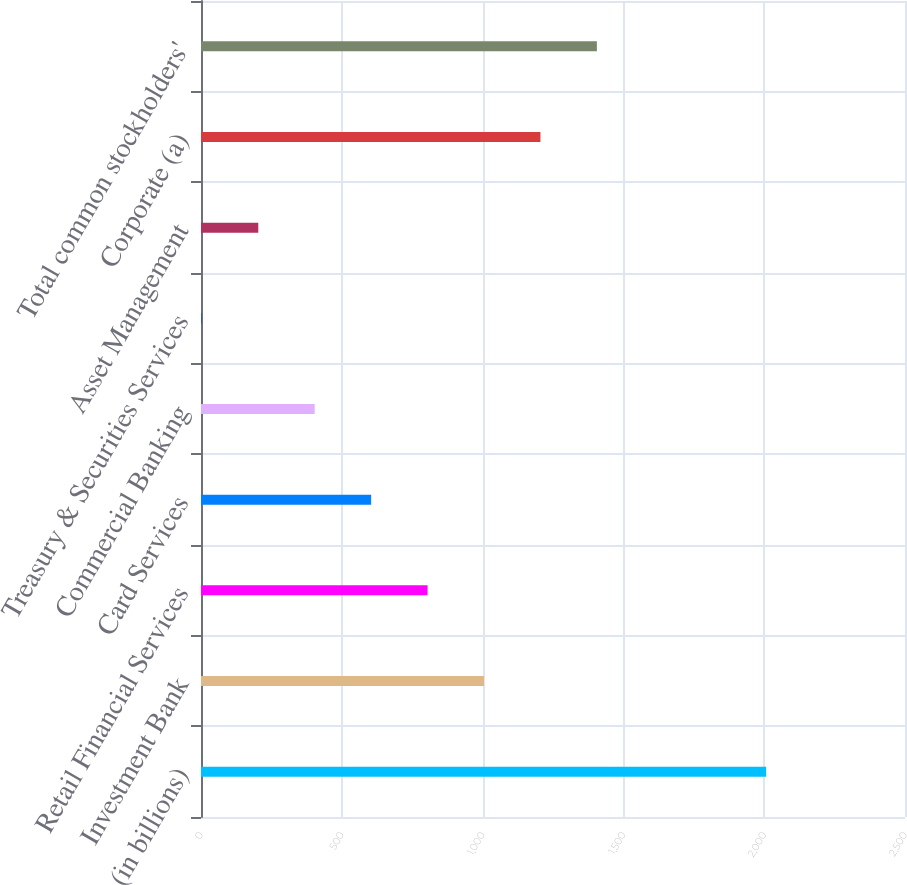Convert chart. <chart><loc_0><loc_0><loc_500><loc_500><bar_chart><fcel>(in billions)<fcel>Investment Bank<fcel>Retail Financial Services<fcel>Card Services<fcel>Commercial Banking<fcel>Treasury & Securities Services<fcel>Asset Management<fcel>Corporate (a)<fcel>Total common stockholders'<nl><fcel>2007<fcel>1005<fcel>804.6<fcel>604.2<fcel>403.8<fcel>3<fcel>203.4<fcel>1205.4<fcel>1405.8<nl></chart> 